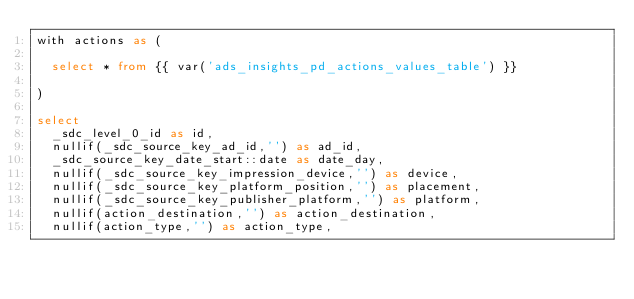<code> <loc_0><loc_0><loc_500><loc_500><_SQL_>with actions as (

  select * from {{ var('ads_insights_pd_actions_values_table') }}

)

select
  _sdc_level_0_id as id,
  nullif(_sdc_source_key_ad_id,'') as ad_id,
  _sdc_source_key_date_start::date as date_day,
  nullif(_sdc_source_key_impression_device,'') as device,
  nullif(_sdc_source_key_platform_position,'') as placement,
  nullif(_sdc_source_key_publisher_platform,'') as platform,
  nullif(action_destination,'') as action_destination,
  nullif(action_type,'') as action_type,</code> 